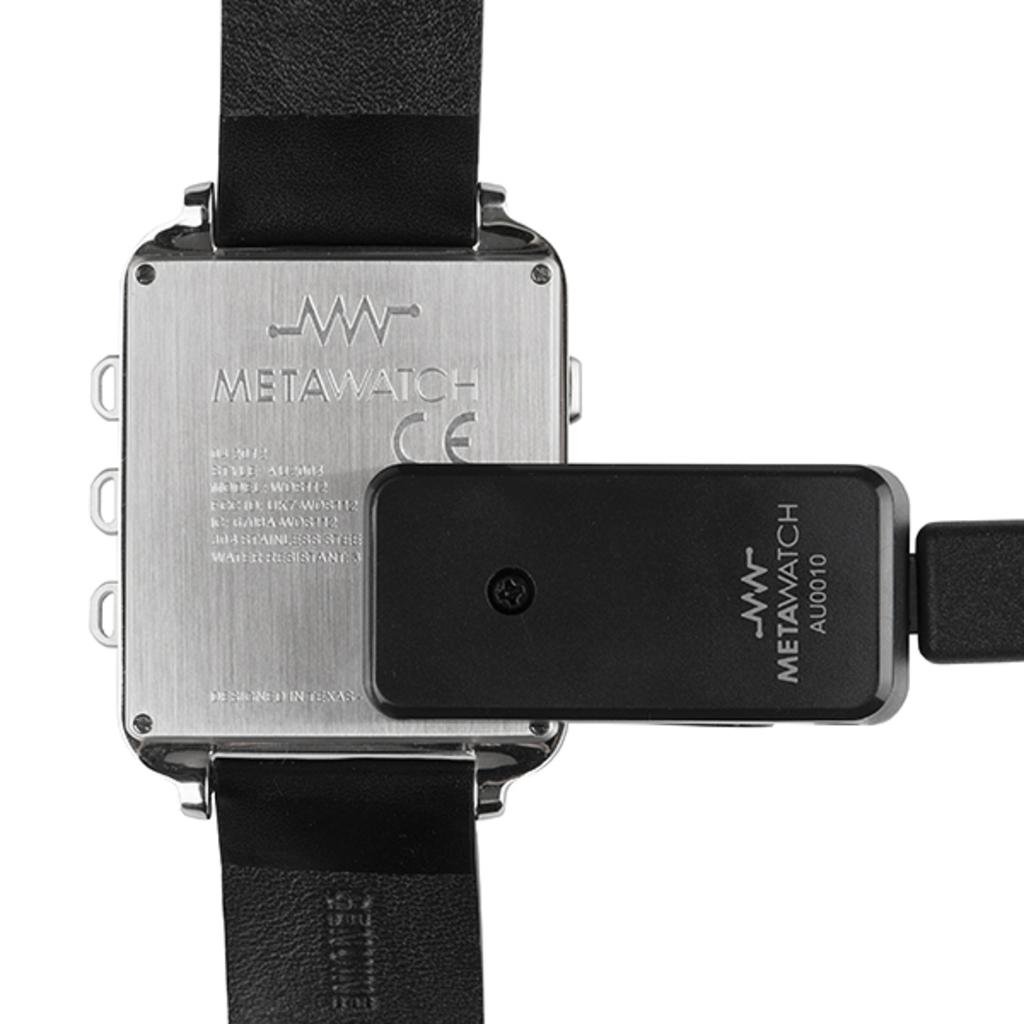<image>
Write a terse but informative summary of the picture. the silver back of a Meta Watch attached to a black leather band 